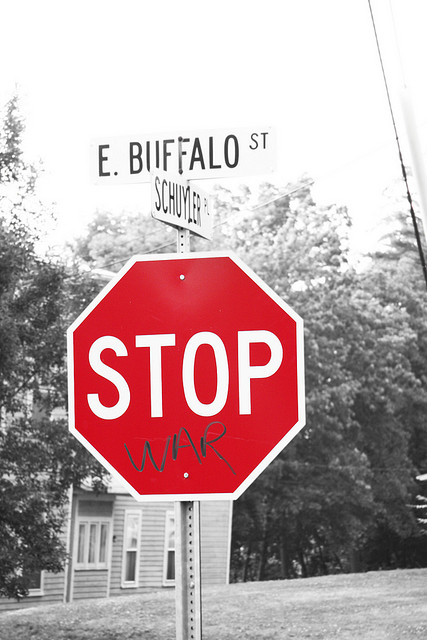<image>Where is this scene taking place at? I am not sure where this scene is taking place. It could be at 'E Buffalo St' or some other street or intersection. Where is this scene taking place at? I don't know where this scene is taking place at. It can be at E Buffalo St or on a street. 